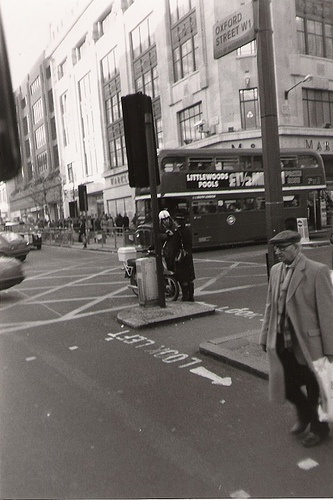Describe the objects in this image and their specific colors. I can see bus in white, black, gray, and darkgray tones, people in white, gray, black, and darkgray tones, traffic light in white, black, gray, darkgray, and lightgray tones, people in white, black, gray, and darkgray tones, and motorcycle in white, black, gray, and darkgray tones in this image. 